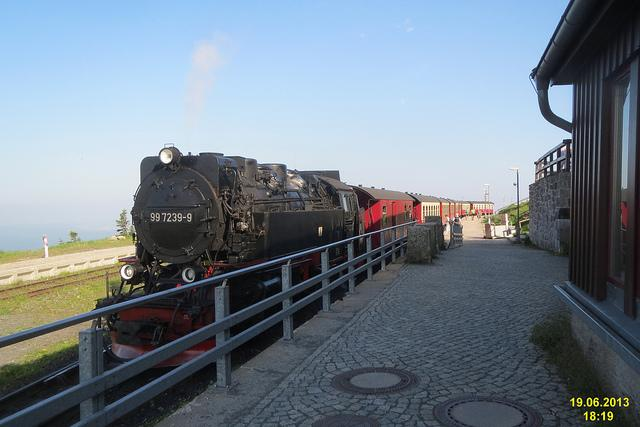Where might someone buy a ticket for this train? train station 